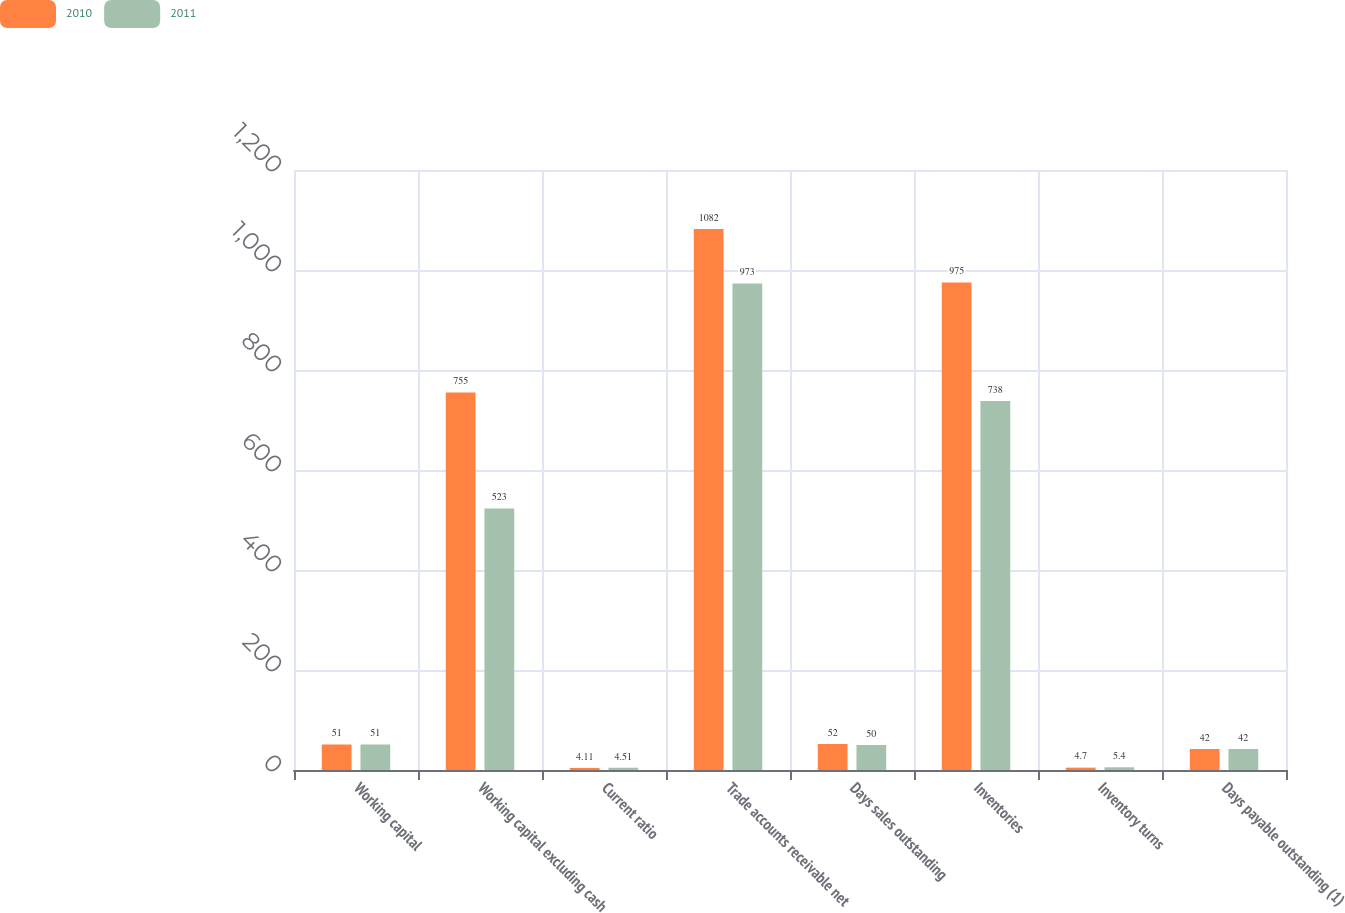Convert chart to OTSL. <chart><loc_0><loc_0><loc_500><loc_500><stacked_bar_chart><ecel><fcel>Working capital<fcel>Working capital excluding cash<fcel>Current ratio<fcel>Trade accounts receivable net<fcel>Days sales outstanding<fcel>Inventories<fcel>Inventory turns<fcel>Days payable outstanding (1)<nl><fcel>2010<fcel>51<fcel>755<fcel>4.11<fcel>1082<fcel>52<fcel>975<fcel>4.7<fcel>42<nl><fcel>2011<fcel>51<fcel>523<fcel>4.51<fcel>973<fcel>50<fcel>738<fcel>5.4<fcel>42<nl></chart> 